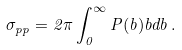Convert formula to latex. <formula><loc_0><loc_0><loc_500><loc_500>\sigma _ { p p } = 2 \pi \int _ { 0 } ^ { \infty } P ( b ) b d b \, .</formula> 